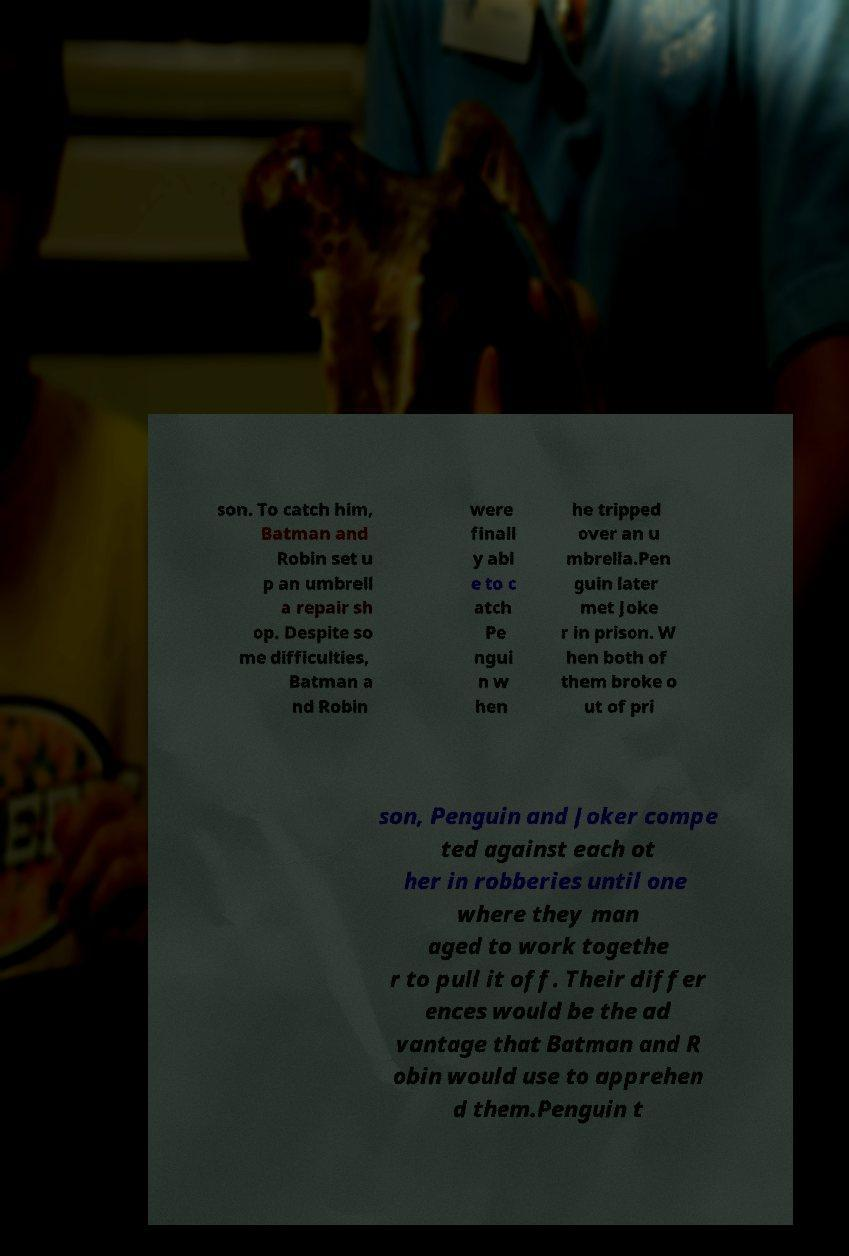There's text embedded in this image that I need extracted. Can you transcribe it verbatim? son. To catch him, Batman and Robin set u p an umbrell a repair sh op. Despite so me difficulties, Batman a nd Robin were finall y abl e to c atch Pe ngui n w hen he tripped over an u mbrella.Pen guin later met Joke r in prison. W hen both of them broke o ut of pri son, Penguin and Joker compe ted against each ot her in robberies until one where they man aged to work togethe r to pull it off. Their differ ences would be the ad vantage that Batman and R obin would use to apprehen d them.Penguin t 